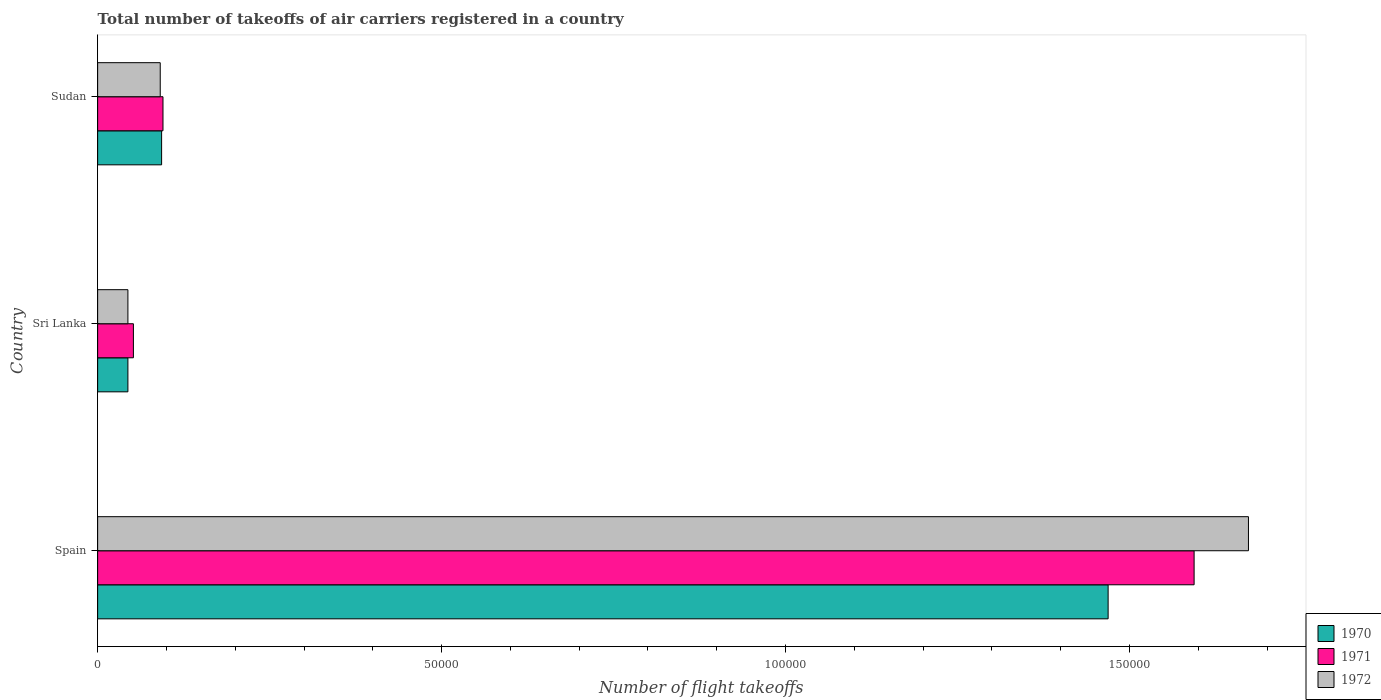How many different coloured bars are there?
Provide a succinct answer. 3. How many groups of bars are there?
Provide a short and direct response. 3. What is the label of the 2nd group of bars from the top?
Provide a succinct answer. Sri Lanka. What is the total number of flight takeoffs in 1970 in Sri Lanka?
Give a very brief answer. 4400. Across all countries, what is the maximum total number of flight takeoffs in 1971?
Your response must be concise. 1.59e+05. Across all countries, what is the minimum total number of flight takeoffs in 1972?
Give a very brief answer. 4400. In which country was the total number of flight takeoffs in 1971 minimum?
Offer a terse response. Sri Lanka. What is the total total number of flight takeoffs in 1972 in the graph?
Provide a succinct answer. 1.81e+05. What is the difference between the total number of flight takeoffs in 1972 in Spain and that in Sudan?
Give a very brief answer. 1.58e+05. What is the difference between the total number of flight takeoffs in 1972 in Spain and the total number of flight takeoffs in 1970 in Sudan?
Ensure brevity in your answer.  1.58e+05. What is the average total number of flight takeoffs in 1971 per country?
Keep it short and to the point. 5.80e+04. What is the difference between the total number of flight takeoffs in 1971 and total number of flight takeoffs in 1970 in Sudan?
Your response must be concise. 200. In how many countries, is the total number of flight takeoffs in 1971 greater than 30000 ?
Provide a succinct answer. 1. What is the ratio of the total number of flight takeoffs in 1970 in Sri Lanka to that in Sudan?
Provide a succinct answer. 0.47. What is the difference between the highest and the second highest total number of flight takeoffs in 1970?
Your answer should be very brief. 1.38e+05. What is the difference between the highest and the lowest total number of flight takeoffs in 1972?
Provide a short and direct response. 1.63e+05. In how many countries, is the total number of flight takeoffs in 1970 greater than the average total number of flight takeoffs in 1970 taken over all countries?
Offer a very short reply. 1. What does the 1st bar from the top in Sri Lanka represents?
Offer a very short reply. 1972. How many bars are there?
Offer a terse response. 9. How many countries are there in the graph?
Offer a terse response. 3. What is the difference between two consecutive major ticks on the X-axis?
Make the answer very short. 5.00e+04. Does the graph contain any zero values?
Your answer should be compact. No. Does the graph contain grids?
Ensure brevity in your answer.  No. How many legend labels are there?
Provide a succinct answer. 3. What is the title of the graph?
Give a very brief answer. Total number of takeoffs of air carriers registered in a country. What is the label or title of the X-axis?
Your answer should be very brief. Number of flight takeoffs. What is the Number of flight takeoffs of 1970 in Spain?
Keep it short and to the point. 1.47e+05. What is the Number of flight takeoffs in 1971 in Spain?
Your response must be concise. 1.59e+05. What is the Number of flight takeoffs of 1972 in Spain?
Give a very brief answer. 1.67e+05. What is the Number of flight takeoffs in 1970 in Sri Lanka?
Offer a terse response. 4400. What is the Number of flight takeoffs in 1971 in Sri Lanka?
Give a very brief answer. 5200. What is the Number of flight takeoffs in 1972 in Sri Lanka?
Ensure brevity in your answer.  4400. What is the Number of flight takeoffs in 1970 in Sudan?
Give a very brief answer. 9300. What is the Number of flight takeoffs in 1971 in Sudan?
Offer a very short reply. 9500. What is the Number of flight takeoffs in 1972 in Sudan?
Your response must be concise. 9100. Across all countries, what is the maximum Number of flight takeoffs of 1970?
Provide a short and direct response. 1.47e+05. Across all countries, what is the maximum Number of flight takeoffs in 1971?
Your response must be concise. 1.59e+05. Across all countries, what is the maximum Number of flight takeoffs in 1972?
Ensure brevity in your answer.  1.67e+05. Across all countries, what is the minimum Number of flight takeoffs of 1970?
Ensure brevity in your answer.  4400. Across all countries, what is the minimum Number of flight takeoffs of 1971?
Make the answer very short. 5200. Across all countries, what is the minimum Number of flight takeoffs in 1972?
Provide a short and direct response. 4400. What is the total Number of flight takeoffs of 1970 in the graph?
Ensure brevity in your answer.  1.61e+05. What is the total Number of flight takeoffs of 1971 in the graph?
Your answer should be compact. 1.74e+05. What is the total Number of flight takeoffs in 1972 in the graph?
Provide a short and direct response. 1.81e+05. What is the difference between the Number of flight takeoffs of 1970 in Spain and that in Sri Lanka?
Your response must be concise. 1.42e+05. What is the difference between the Number of flight takeoffs of 1971 in Spain and that in Sri Lanka?
Your answer should be very brief. 1.54e+05. What is the difference between the Number of flight takeoffs in 1972 in Spain and that in Sri Lanka?
Ensure brevity in your answer.  1.63e+05. What is the difference between the Number of flight takeoffs of 1970 in Spain and that in Sudan?
Make the answer very short. 1.38e+05. What is the difference between the Number of flight takeoffs in 1971 in Spain and that in Sudan?
Offer a very short reply. 1.50e+05. What is the difference between the Number of flight takeoffs of 1972 in Spain and that in Sudan?
Your answer should be compact. 1.58e+05. What is the difference between the Number of flight takeoffs in 1970 in Sri Lanka and that in Sudan?
Make the answer very short. -4900. What is the difference between the Number of flight takeoffs of 1971 in Sri Lanka and that in Sudan?
Make the answer very short. -4300. What is the difference between the Number of flight takeoffs in 1972 in Sri Lanka and that in Sudan?
Provide a short and direct response. -4700. What is the difference between the Number of flight takeoffs in 1970 in Spain and the Number of flight takeoffs in 1971 in Sri Lanka?
Provide a succinct answer. 1.42e+05. What is the difference between the Number of flight takeoffs of 1970 in Spain and the Number of flight takeoffs of 1972 in Sri Lanka?
Provide a short and direct response. 1.42e+05. What is the difference between the Number of flight takeoffs of 1971 in Spain and the Number of flight takeoffs of 1972 in Sri Lanka?
Make the answer very short. 1.55e+05. What is the difference between the Number of flight takeoffs in 1970 in Spain and the Number of flight takeoffs in 1971 in Sudan?
Ensure brevity in your answer.  1.37e+05. What is the difference between the Number of flight takeoffs of 1970 in Spain and the Number of flight takeoffs of 1972 in Sudan?
Ensure brevity in your answer.  1.38e+05. What is the difference between the Number of flight takeoffs of 1971 in Spain and the Number of flight takeoffs of 1972 in Sudan?
Ensure brevity in your answer.  1.50e+05. What is the difference between the Number of flight takeoffs of 1970 in Sri Lanka and the Number of flight takeoffs of 1971 in Sudan?
Provide a short and direct response. -5100. What is the difference between the Number of flight takeoffs in 1970 in Sri Lanka and the Number of flight takeoffs in 1972 in Sudan?
Keep it short and to the point. -4700. What is the difference between the Number of flight takeoffs in 1971 in Sri Lanka and the Number of flight takeoffs in 1972 in Sudan?
Make the answer very short. -3900. What is the average Number of flight takeoffs of 1970 per country?
Provide a succinct answer. 5.35e+04. What is the average Number of flight takeoffs of 1971 per country?
Your answer should be very brief. 5.80e+04. What is the average Number of flight takeoffs of 1972 per country?
Your answer should be very brief. 6.03e+04. What is the difference between the Number of flight takeoffs in 1970 and Number of flight takeoffs in 1971 in Spain?
Offer a terse response. -1.25e+04. What is the difference between the Number of flight takeoffs in 1970 and Number of flight takeoffs in 1972 in Spain?
Offer a very short reply. -2.04e+04. What is the difference between the Number of flight takeoffs of 1971 and Number of flight takeoffs of 1972 in Spain?
Your response must be concise. -7900. What is the difference between the Number of flight takeoffs in 1970 and Number of flight takeoffs in 1971 in Sri Lanka?
Make the answer very short. -800. What is the difference between the Number of flight takeoffs of 1971 and Number of flight takeoffs of 1972 in Sri Lanka?
Provide a short and direct response. 800. What is the difference between the Number of flight takeoffs of 1970 and Number of flight takeoffs of 1971 in Sudan?
Make the answer very short. -200. What is the difference between the Number of flight takeoffs of 1970 and Number of flight takeoffs of 1972 in Sudan?
Provide a short and direct response. 200. What is the ratio of the Number of flight takeoffs of 1970 in Spain to that in Sri Lanka?
Your answer should be compact. 33.39. What is the ratio of the Number of flight takeoffs in 1971 in Spain to that in Sri Lanka?
Offer a very short reply. 30.65. What is the ratio of the Number of flight takeoffs of 1972 in Spain to that in Sri Lanka?
Give a very brief answer. 38.02. What is the ratio of the Number of flight takeoffs of 1970 in Spain to that in Sudan?
Offer a very short reply. 15.8. What is the ratio of the Number of flight takeoffs in 1971 in Spain to that in Sudan?
Give a very brief answer. 16.78. What is the ratio of the Number of flight takeoffs in 1972 in Spain to that in Sudan?
Provide a short and direct response. 18.38. What is the ratio of the Number of flight takeoffs in 1970 in Sri Lanka to that in Sudan?
Your answer should be very brief. 0.47. What is the ratio of the Number of flight takeoffs in 1971 in Sri Lanka to that in Sudan?
Your response must be concise. 0.55. What is the ratio of the Number of flight takeoffs in 1972 in Sri Lanka to that in Sudan?
Provide a short and direct response. 0.48. What is the difference between the highest and the second highest Number of flight takeoffs of 1970?
Keep it short and to the point. 1.38e+05. What is the difference between the highest and the second highest Number of flight takeoffs in 1971?
Make the answer very short. 1.50e+05. What is the difference between the highest and the second highest Number of flight takeoffs in 1972?
Your response must be concise. 1.58e+05. What is the difference between the highest and the lowest Number of flight takeoffs of 1970?
Ensure brevity in your answer.  1.42e+05. What is the difference between the highest and the lowest Number of flight takeoffs in 1971?
Ensure brevity in your answer.  1.54e+05. What is the difference between the highest and the lowest Number of flight takeoffs of 1972?
Offer a very short reply. 1.63e+05. 